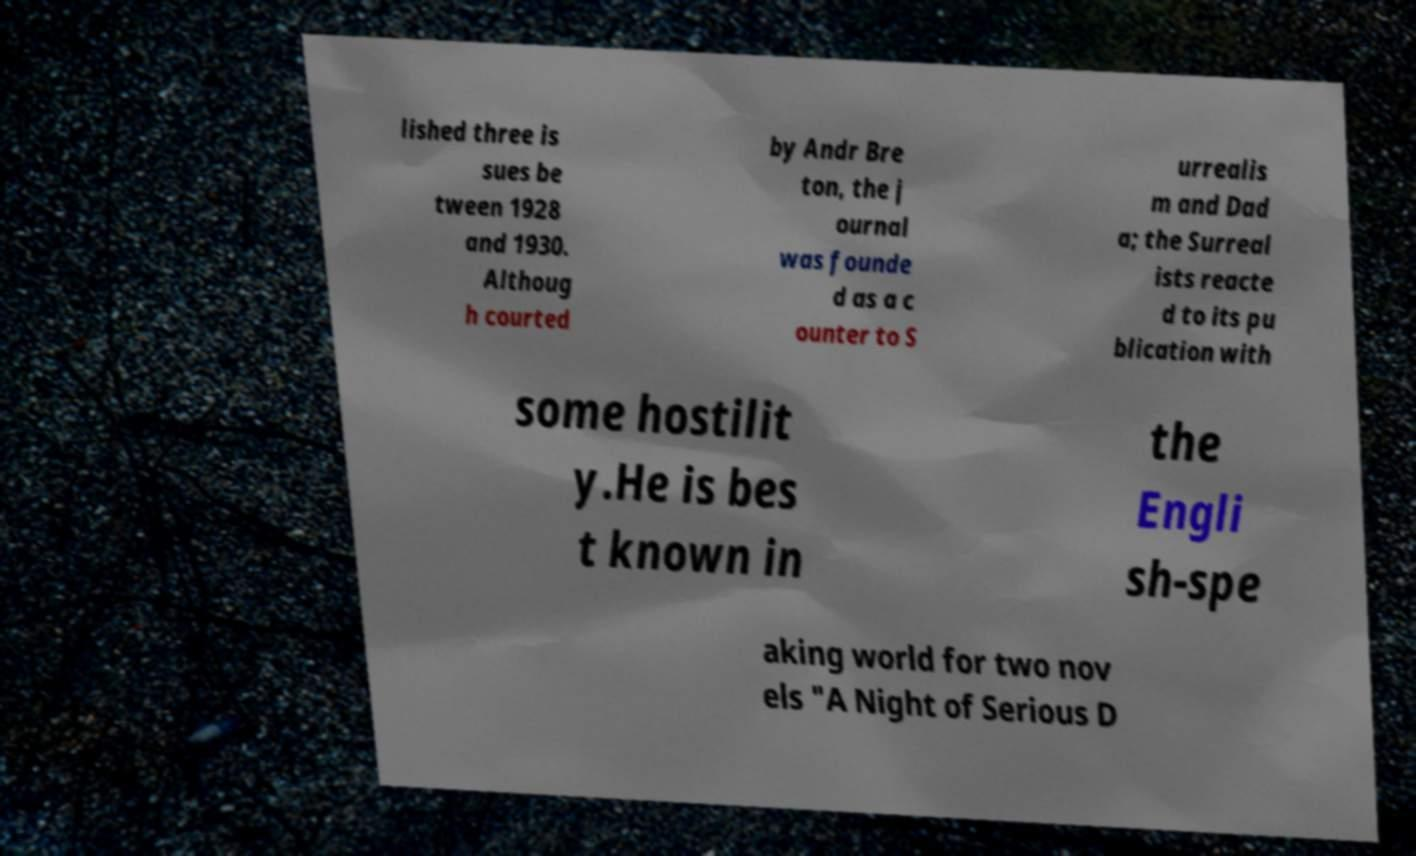Could you assist in decoding the text presented in this image and type it out clearly? lished three is sues be tween 1928 and 1930. Althoug h courted by Andr Bre ton, the j ournal was founde d as a c ounter to S urrealis m and Dad a; the Surreal ists reacte d to its pu blication with some hostilit y.He is bes t known in the Engli sh-spe aking world for two nov els "A Night of Serious D 